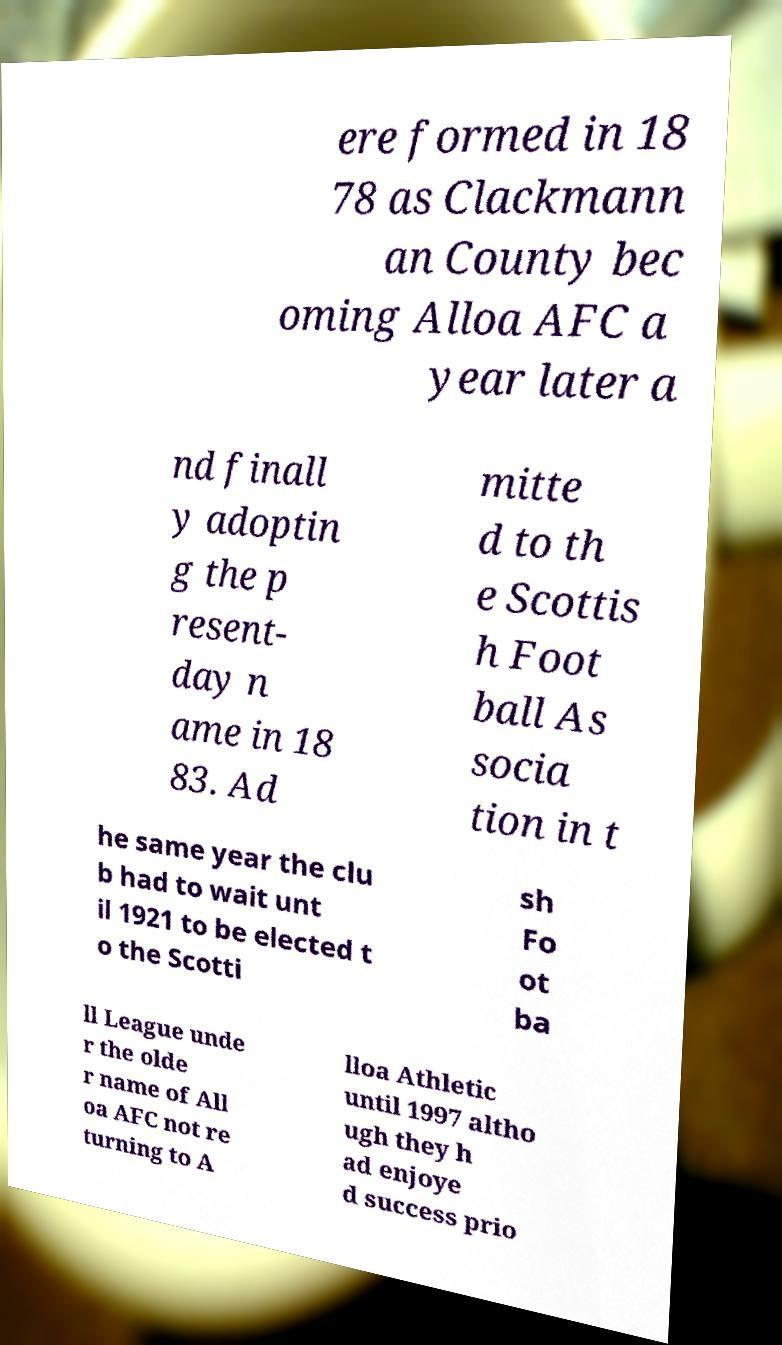Could you extract and type out the text from this image? ere formed in 18 78 as Clackmann an County bec oming Alloa AFC a year later a nd finall y adoptin g the p resent- day n ame in 18 83. Ad mitte d to th e Scottis h Foot ball As socia tion in t he same year the clu b had to wait unt il 1921 to be elected t o the Scotti sh Fo ot ba ll League unde r the olde r name of All oa AFC not re turning to A lloa Athletic until 1997 altho ugh they h ad enjoye d success prio 